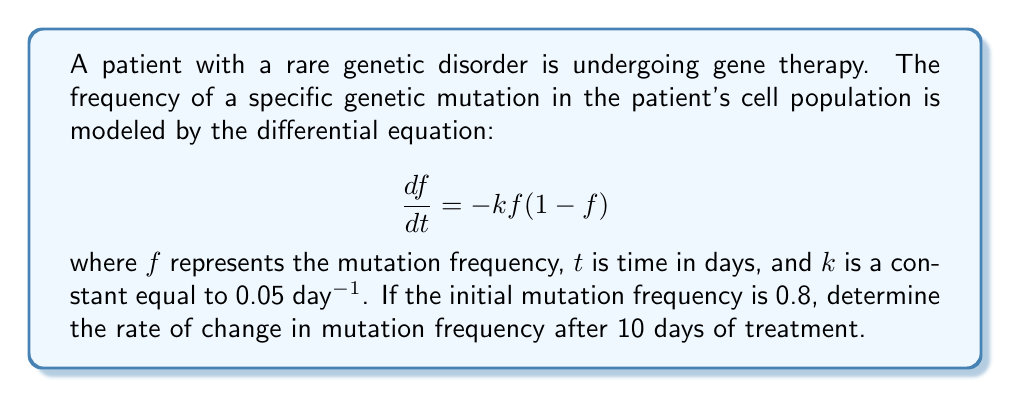What is the answer to this math problem? To solve this problem, we need to follow these steps:

1) First, we need to find the mutation frequency $f$ at $t = 10$ days. The given differential equation is a logistic decay model, which has the following solution:

   $$f(t) = \frac{f_0}{f_0 + (1-f_0)e^{kt}}$$

   where $f_0$ is the initial mutation frequency.

2) We're given that $f_0 = 0.8$, $k = 0.05$ day⁻¹, and we need to find $f(10)$:

   $$f(10) = \frac{0.8}{0.8 + (1-0.8)e^{0.05 \cdot 10}}$$

3) Simplifying:
   
   $$f(10) = \frac{0.8}{0.8 + 0.2e^{0.5}} \approx 0.6185$$

4) Now that we have $f(10)$, we can use the original differential equation to find the rate of change at $t = 10$:

   $$\frac{df}{dt} = -kf(1-f)$$

5) Substituting the values:

   $$\frac{df}{dt} = -0.05 \cdot 0.6185 \cdot (1-0.6185)$$

6) Calculating:

   $$\frac{df}{dt} \approx -0.01181 \text{ day}^{-1}$$

This negative value indicates that the mutation frequency is decreasing at this rate after 10 days of treatment.
Answer: $-0.01181 \text{ day}^{-1}$ 